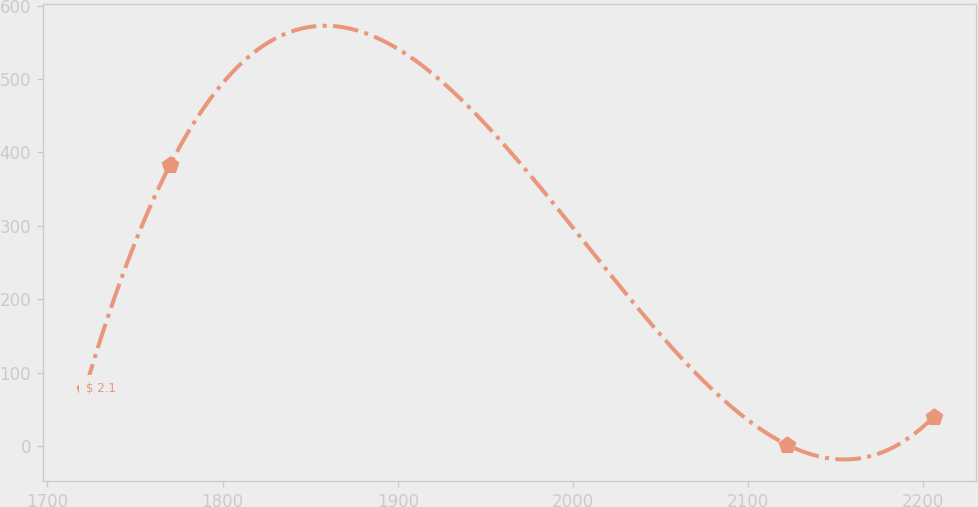Convert chart. <chart><loc_0><loc_0><loc_500><loc_500><line_chart><ecel><fcel>$ 2.1<nl><fcel>1721.66<fcel>78.05<nl><fcel>1770.09<fcel>383.2<nl><fcel>2122.12<fcel>1.75<nl><fcel>2205.95<fcel>39.9<nl></chart> 